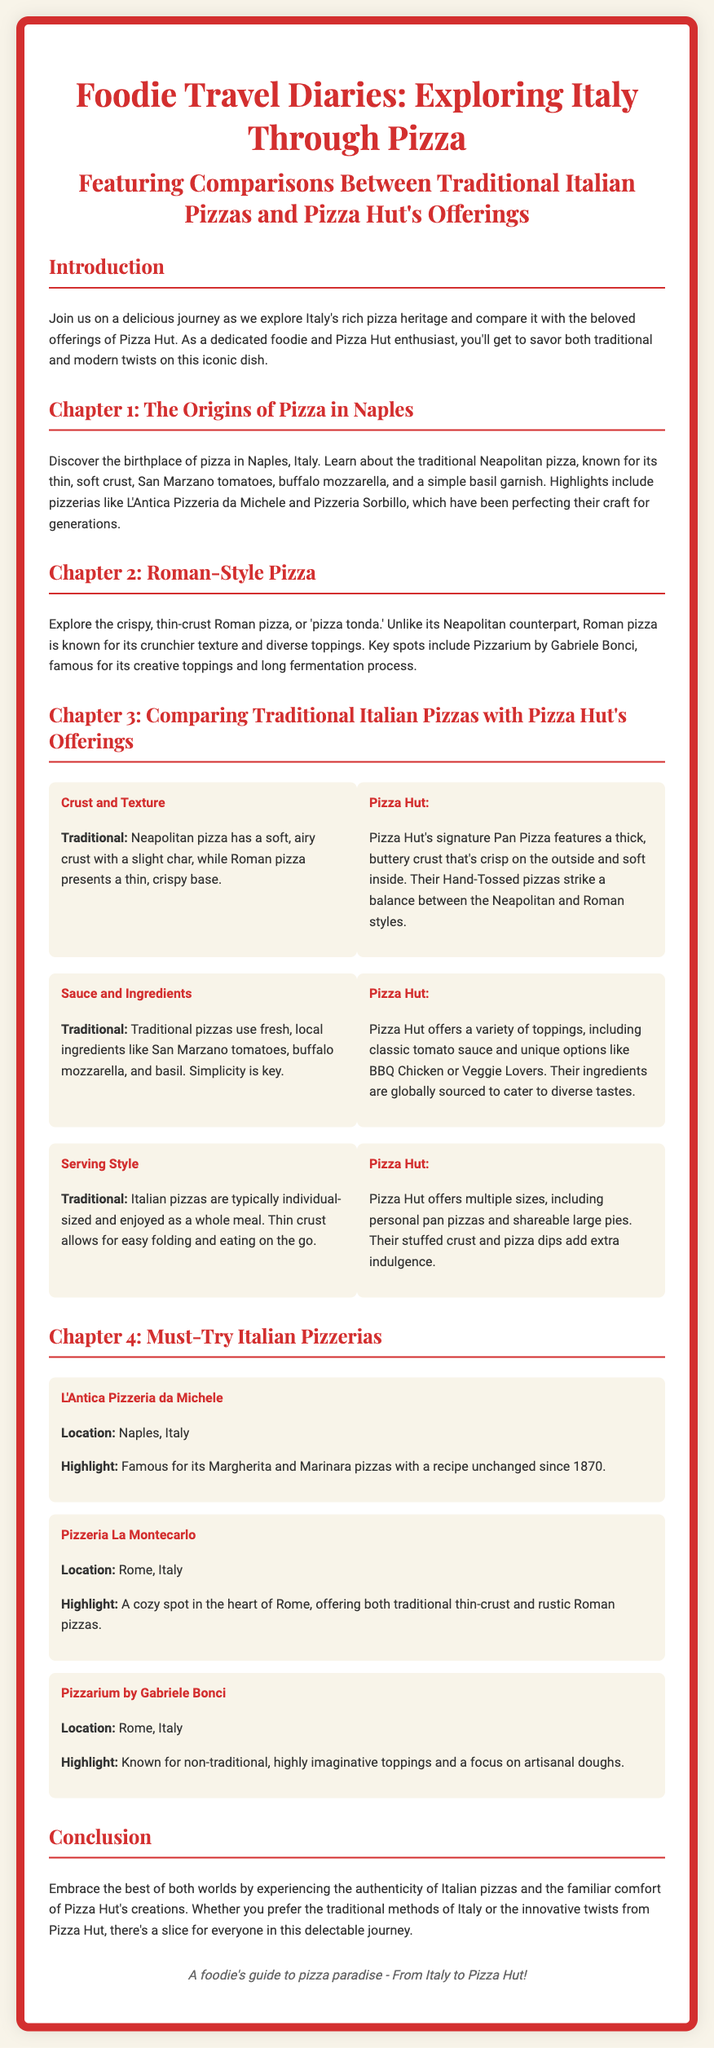What is the title of the document? The title is mentioned prominently at the beginning of the document.
Answer: Foodie Travel Diaries: Exploring Italy Through Pizza What city is known as the birthplace of pizza? The document states that pizza originated in Naples, Italy.
Answer: Naples What type of crust does Neapolitan pizza have? The document describes Neapolitan pizza having a soft, airy crust.
Answer: Soft, airy crust What pizzeria in Naples is famous for its Margherita pizza? The document specifically mentions L'Antica Pizzeria da Michele for its Margherita pizza.
Answer: L'Antica Pizzeria da Michele What is a key feature of Pizza Hut's Pan Pizza? The document highlights that Pizza Hut's Pan Pizza features a thick, buttery crust.
Answer: Thick, buttery crust What ingredient is emphasized as a key feature of traditional Italian pizzas? The document mentions using fresh, local ingredients like San Marzano tomatoes.
Answer: San Marzano tomatoes How do Italian pizzas typically differ in serving style compared to Pizza Hut? The document states traditional pizzas are usually individual-sized, unlike Pizza Hut's various sizes.
Answer: Individual-sized Which pizzeria is known for imaginative toppings? The document identifies Pizzarium by Gabriele Bonci as known for its non-traditional toppings.
Answer: Pizzarium by Gabriele Bonci What cuisine is compared in this document? The document compares traditional Italian pizzas with offerings from Pizza Hut.
Answer: Traditional Italian pizzas and Pizza Hut's offerings 